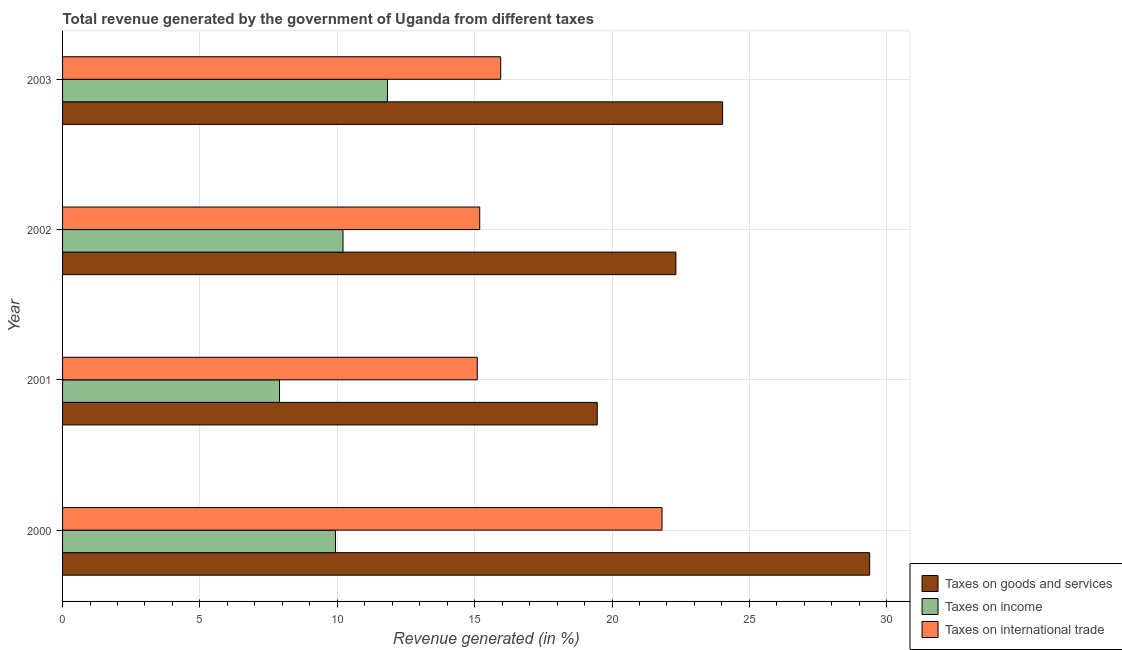How many different coloured bars are there?
Give a very brief answer. 3. Are the number of bars per tick equal to the number of legend labels?
Give a very brief answer. Yes. Are the number of bars on each tick of the Y-axis equal?
Give a very brief answer. Yes. How many bars are there on the 4th tick from the top?
Offer a terse response. 3. In how many cases, is the number of bars for a given year not equal to the number of legend labels?
Provide a succinct answer. 0. What is the percentage of revenue generated by tax on international trade in 2000?
Offer a terse response. 21.82. Across all years, what is the maximum percentage of revenue generated by taxes on goods and services?
Offer a terse response. 29.38. Across all years, what is the minimum percentage of revenue generated by taxes on income?
Your answer should be compact. 7.9. In which year was the percentage of revenue generated by tax on international trade minimum?
Offer a very short reply. 2001. What is the total percentage of revenue generated by taxes on income in the graph?
Ensure brevity in your answer.  39.86. What is the difference between the percentage of revenue generated by tax on international trade in 2000 and that in 2002?
Keep it short and to the point. 6.63. What is the difference between the percentage of revenue generated by taxes on income in 2001 and the percentage of revenue generated by taxes on goods and services in 2002?
Ensure brevity in your answer.  -14.43. What is the average percentage of revenue generated by tax on international trade per year?
Offer a very short reply. 17.01. In the year 2002, what is the difference between the percentage of revenue generated by taxes on income and percentage of revenue generated by tax on international trade?
Provide a short and direct response. -4.98. In how many years, is the percentage of revenue generated by tax on international trade greater than 3 %?
Your answer should be compact. 4. What is the ratio of the percentage of revenue generated by taxes on income in 2000 to that in 2003?
Offer a terse response. 0.84. Is the difference between the percentage of revenue generated by taxes on goods and services in 2000 and 2001 greater than the difference between the percentage of revenue generated by tax on international trade in 2000 and 2001?
Your answer should be very brief. Yes. What is the difference between the highest and the second highest percentage of revenue generated by taxes on income?
Your response must be concise. 1.62. What is the difference between the highest and the lowest percentage of revenue generated by tax on international trade?
Make the answer very short. 6.73. In how many years, is the percentage of revenue generated by taxes on goods and services greater than the average percentage of revenue generated by taxes on goods and services taken over all years?
Provide a succinct answer. 2. Is the sum of the percentage of revenue generated by taxes on goods and services in 2001 and 2002 greater than the maximum percentage of revenue generated by tax on international trade across all years?
Your answer should be very brief. Yes. What does the 2nd bar from the top in 2001 represents?
Give a very brief answer. Taxes on income. What does the 1st bar from the bottom in 2000 represents?
Keep it short and to the point. Taxes on goods and services. How many bars are there?
Your response must be concise. 12. Are all the bars in the graph horizontal?
Give a very brief answer. Yes. What is the difference between two consecutive major ticks on the X-axis?
Give a very brief answer. 5. Are the values on the major ticks of X-axis written in scientific E-notation?
Keep it short and to the point. No. Does the graph contain any zero values?
Provide a short and direct response. No. How many legend labels are there?
Make the answer very short. 3. What is the title of the graph?
Ensure brevity in your answer.  Total revenue generated by the government of Uganda from different taxes. Does "Communicable diseases" appear as one of the legend labels in the graph?
Give a very brief answer. No. What is the label or title of the X-axis?
Offer a very short reply. Revenue generated (in %). What is the label or title of the Y-axis?
Your answer should be very brief. Year. What is the Revenue generated (in %) of Taxes on goods and services in 2000?
Your response must be concise. 29.38. What is the Revenue generated (in %) of Taxes on income in 2000?
Offer a very short reply. 9.93. What is the Revenue generated (in %) in Taxes on international trade in 2000?
Keep it short and to the point. 21.82. What is the Revenue generated (in %) in Taxes on goods and services in 2001?
Provide a succinct answer. 19.46. What is the Revenue generated (in %) in Taxes on income in 2001?
Your answer should be very brief. 7.9. What is the Revenue generated (in %) in Taxes on international trade in 2001?
Your answer should be very brief. 15.1. What is the Revenue generated (in %) in Taxes on goods and services in 2002?
Keep it short and to the point. 22.33. What is the Revenue generated (in %) of Taxes on income in 2002?
Keep it short and to the point. 10.21. What is the Revenue generated (in %) in Taxes on international trade in 2002?
Make the answer very short. 15.19. What is the Revenue generated (in %) of Taxes on goods and services in 2003?
Your answer should be compact. 24.03. What is the Revenue generated (in %) in Taxes on income in 2003?
Keep it short and to the point. 11.83. What is the Revenue generated (in %) of Taxes on international trade in 2003?
Provide a succinct answer. 15.95. Across all years, what is the maximum Revenue generated (in %) in Taxes on goods and services?
Your answer should be compact. 29.38. Across all years, what is the maximum Revenue generated (in %) of Taxes on income?
Ensure brevity in your answer.  11.83. Across all years, what is the maximum Revenue generated (in %) of Taxes on international trade?
Keep it short and to the point. 21.82. Across all years, what is the minimum Revenue generated (in %) in Taxes on goods and services?
Provide a succinct answer. 19.46. Across all years, what is the minimum Revenue generated (in %) of Taxes on income?
Ensure brevity in your answer.  7.9. Across all years, what is the minimum Revenue generated (in %) of Taxes on international trade?
Give a very brief answer. 15.1. What is the total Revenue generated (in %) of Taxes on goods and services in the graph?
Make the answer very short. 95.19. What is the total Revenue generated (in %) in Taxes on income in the graph?
Your answer should be compact. 39.86. What is the total Revenue generated (in %) of Taxes on international trade in the graph?
Keep it short and to the point. 68.05. What is the difference between the Revenue generated (in %) of Taxes on goods and services in 2000 and that in 2001?
Provide a succinct answer. 9.92. What is the difference between the Revenue generated (in %) of Taxes on income in 2000 and that in 2001?
Make the answer very short. 2.04. What is the difference between the Revenue generated (in %) in Taxes on international trade in 2000 and that in 2001?
Ensure brevity in your answer.  6.73. What is the difference between the Revenue generated (in %) in Taxes on goods and services in 2000 and that in 2002?
Give a very brief answer. 7.05. What is the difference between the Revenue generated (in %) in Taxes on income in 2000 and that in 2002?
Make the answer very short. -0.28. What is the difference between the Revenue generated (in %) of Taxes on international trade in 2000 and that in 2002?
Give a very brief answer. 6.64. What is the difference between the Revenue generated (in %) of Taxes on goods and services in 2000 and that in 2003?
Your answer should be compact. 5.35. What is the difference between the Revenue generated (in %) of Taxes on income in 2000 and that in 2003?
Offer a terse response. -1.89. What is the difference between the Revenue generated (in %) in Taxes on international trade in 2000 and that in 2003?
Offer a terse response. 5.87. What is the difference between the Revenue generated (in %) of Taxes on goods and services in 2001 and that in 2002?
Offer a terse response. -2.86. What is the difference between the Revenue generated (in %) of Taxes on income in 2001 and that in 2002?
Provide a short and direct response. -2.31. What is the difference between the Revenue generated (in %) of Taxes on international trade in 2001 and that in 2002?
Provide a short and direct response. -0.09. What is the difference between the Revenue generated (in %) in Taxes on goods and services in 2001 and that in 2003?
Your answer should be compact. -4.56. What is the difference between the Revenue generated (in %) of Taxes on income in 2001 and that in 2003?
Offer a very short reply. -3.93. What is the difference between the Revenue generated (in %) of Taxes on international trade in 2001 and that in 2003?
Offer a very short reply. -0.85. What is the difference between the Revenue generated (in %) of Taxes on goods and services in 2002 and that in 2003?
Your answer should be compact. -1.7. What is the difference between the Revenue generated (in %) in Taxes on income in 2002 and that in 2003?
Provide a short and direct response. -1.62. What is the difference between the Revenue generated (in %) in Taxes on international trade in 2002 and that in 2003?
Make the answer very short. -0.76. What is the difference between the Revenue generated (in %) of Taxes on goods and services in 2000 and the Revenue generated (in %) of Taxes on income in 2001?
Your answer should be very brief. 21.48. What is the difference between the Revenue generated (in %) of Taxes on goods and services in 2000 and the Revenue generated (in %) of Taxes on international trade in 2001?
Ensure brevity in your answer.  14.28. What is the difference between the Revenue generated (in %) in Taxes on income in 2000 and the Revenue generated (in %) in Taxes on international trade in 2001?
Your answer should be very brief. -5.16. What is the difference between the Revenue generated (in %) in Taxes on goods and services in 2000 and the Revenue generated (in %) in Taxes on income in 2002?
Offer a very short reply. 19.17. What is the difference between the Revenue generated (in %) of Taxes on goods and services in 2000 and the Revenue generated (in %) of Taxes on international trade in 2002?
Make the answer very short. 14.19. What is the difference between the Revenue generated (in %) in Taxes on income in 2000 and the Revenue generated (in %) in Taxes on international trade in 2002?
Your answer should be compact. -5.25. What is the difference between the Revenue generated (in %) in Taxes on goods and services in 2000 and the Revenue generated (in %) in Taxes on income in 2003?
Give a very brief answer. 17.55. What is the difference between the Revenue generated (in %) in Taxes on goods and services in 2000 and the Revenue generated (in %) in Taxes on international trade in 2003?
Provide a succinct answer. 13.43. What is the difference between the Revenue generated (in %) in Taxes on income in 2000 and the Revenue generated (in %) in Taxes on international trade in 2003?
Your response must be concise. -6.01. What is the difference between the Revenue generated (in %) in Taxes on goods and services in 2001 and the Revenue generated (in %) in Taxes on income in 2002?
Provide a short and direct response. 9.25. What is the difference between the Revenue generated (in %) in Taxes on goods and services in 2001 and the Revenue generated (in %) in Taxes on international trade in 2002?
Offer a very short reply. 4.28. What is the difference between the Revenue generated (in %) of Taxes on income in 2001 and the Revenue generated (in %) of Taxes on international trade in 2002?
Offer a terse response. -7.29. What is the difference between the Revenue generated (in %) of Taxes on goods and services in 2001 and the Revenue generated (in %) of Taxes on income in 2003?
Ensure brevity in your answer.  7.64. What is the difference between the Revenue generated (in %) of Taxes on goods and services in 2001 and the Revenue generated (in %) of Taxes on international trade in 2003?
Ensure brevity in your answer.  3.52. What is the difference between the Revenue generated (in %) in Taxes on income in 2001 and the Revenue generated (in %) in Taxes on international trade in 2003?
Offer a very short reply. -8.05. What is the difference between the Revenue generated (in %) in Taxes on goods and services in 2002 and the Revenue generated (in %) in Taxes on income in 2003?
Provide a short and direct response. 10.5. What is the difference between the Revenue generated (in %) in Taxes on goods and services in 2002 and the Revenue generated (in %) in Taxes on international trade in 2003?
Your response must be concise. 6.38. What is the difference between the Revenue generated (in %) of Taxes on income in 2002 and the Revenue generated (in %) of Taxes on international trade in 2003?
Your answer should be compact. -5.74. What is the average Revenue generated (in %) in Taxes on goods and services per year?
Your answer should be very brief. 23.8. What is the average Revenue generated (in %) of Taxes on income per year?
Your answer should be very brief. 9.97. What is the average Revenue generated (in %) of Taxes on international trade per year?
Keep it short and to the point. 17.01. In the year 2000, what is the difference between the Revenue generated (in %) in Taxes on goods and services and Revenue generated (in %) in Taxes on income?
Your response must be concise. 19.45. In the year 2000, what is the difference between the Revenue generated (in %) of Taxes on goods and services and Revenue generated (in %) of Taxes on international trade?
Give a very brief answer. 7.56. In the year 2000, what is the difference between the Revenue generated (in %) of Taxes on income and Revenue generated (in %) of Taxes on international trade?
Make the answer very short. -11.89. In the year 2001, what is the difference between the Revenue generated (in %) of Taxes on goods and services and Revenue generated (in %) of Taxes on income?
Your answer should be compact. 11.57. In the year 2001, what is the difference between the Revenue generated (in %) of Taxes on goods and services and Revenue generated (in %) of Taxes on international trade?
Make the answer very short. 4.37. In the year 2001, what is the difference between the Revenue generated (in %) in Taxes on income and Revenue generated (in %) in Taxes on international trade?
Your answer should be compact. -7.2. In the year 2002, what is the difference between the Revenue generated (in %) of Taxes on goods and services and Revenue generated (in %) of Taxes on income?
Provide a short and direct response. 12.12. In the year 2002, what is the difference between the Revenue generated (in %) of Taxes on goods and services and Revenue generated (in %) of Taxes on international trade?
Your answer should be very brief. 7.14. In the year 2002, what is the difference between the Revenue generated (in %) in Taxes on income and Revenue generated (in %) in Taxes on international trade?
Give a very brief answer. -4.98. In the year 2003, what is the difference between the Revenue generated (in %) of Taxes on goods and services and Revenue generated (in %) of Taxes on income?
Your answer should be very brief. 12.2. In the year 2003, what is the difference between the Revenue generated (in %) of Taxes on goods and services and Revenue generated (in %) of Taxes on international trade?
Offer a very short reply. 8.08. In the year 2003, what is the difference between the Revenue generated (in %) in Taxes on income and Revenue generated (in %) in Taxes on international trade?
Keep it short and to the point. -4.12. What is the ratio of the Revenue generated (in %) in Taxes on goods and services in 2000 to that in 2001?
Offer a terse response. 1.51. What is the ratio of the Revenue generated (in %) of Taxes on income in 2000 to that in 2001?
Your answer should be compact. 1.26. What is the ratio of the Revenue generated (in %) of Taxes on international trade in 2000 to that in 2001?
Your response must be concise. 1.45. What is the ratio of the Revenue generated (in %) of Taxes on goods and services in 2000 to that in 2002?
Your response must be concise. 1.32. What is the ratio of the Revenue generated (in %) of Taxes on international trade in 2000 to that in 2002?
Your response must be concise. 1.44. What is the ratio of the Revenue generated (in %) in Taxes on goods and services in 2000 to that in 2003?
Offer a very short reply. 1.22. What is the ratio of the Revenue generated (in %) of Taxes on income in 2000 to that in 2003?
Offer a very short reply. 0.84. What is the ratio of the Revenue generated (in %) of Taxes on international trade in 2000 to that in 2003?
Make the answer very short. 1.37. What is the ratio of the Revenue generated (in %) in Taxes on goods and services in 2001 to that in 2002?
Ensure brevity in your answer.  0.87. What is the ratio of the Revenue generated (in %) of Taxes on income in 2001 to that in 2002?
Provide a short and direct response. 0.77. What is the ratio of the Revenue generated (in %) of Taxes on goods and services in 2001 to that in 2003?
Provide a short and direct response. 0.81. What is the ratio of the Revenue generated (in %) in Taxes on income in 2001 to that in 2003?
Your answer should be compact. 0.67. What is the ratio of the Revenue generated (in %) in Taxes on international trade in 2001 to that in 2003?
Offer a terse response. 0.95. What is the ratio of the Revenue generated (in %) in Taxes on goods and services in 2002 to that in 2003?
Your response must be concise. 0.93. What is the ratio of the Revenue generated (in %) of Taxes on income in 2002 to that in 2003?
Your answer should be very brief. 0.86. What is the ratio of the Revenue generated (in %) of Taxes on international trade in 2002 to that in 2003?
Provide a short and direct response. 0.95. What is the difference between the highest and the second highest Revenue generated (in %) of Taxes on goods and services?
Keep it short and to the point. 5.35. What is the difference between the highest and the second highest Revenue generated (in %) in Taxes on income?
Provide a succinct answer. 1.62. What is the difference between the highest and the second highest Revenue generated (in %) of Taxes on international trade?
Your answer should be very brief. 5.87. What is the difference between the highest and the lowest Revenue generated (in %) of Taxes on goods and services?
Keep it short and to the point. 9.92. What is the difference between the highest and the lowest Revenue generated (in %) in Taxes on income?
Offer a very short reply. 3.93. What is the difference between the highest and the lowest Revenue generated (in %) in Taxes on international trade?
Keep it short and to the point. 6.73. 